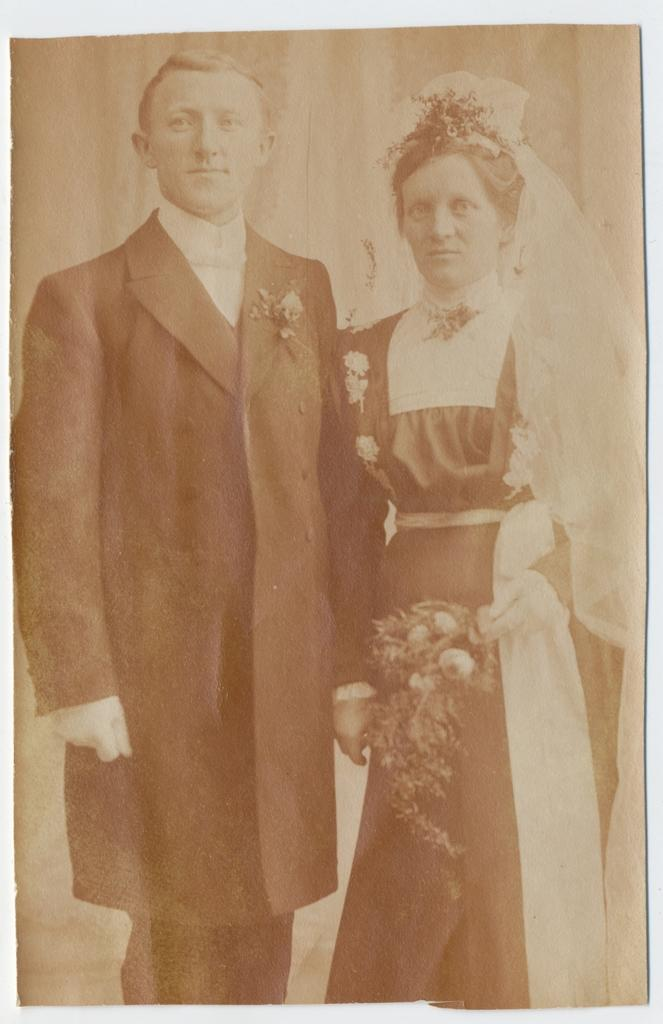What are the two people doing in the image? There is a man and a lady standing in the image. What is the lady holding in her hand? The lady is holding flowers in her hand. What type of wrench is the man using in the image? There is no wrench present in the image; the man is simply standing. How many beads can be seen on the lady's necklace in the image? There is no necklace or beads visible in the image. 